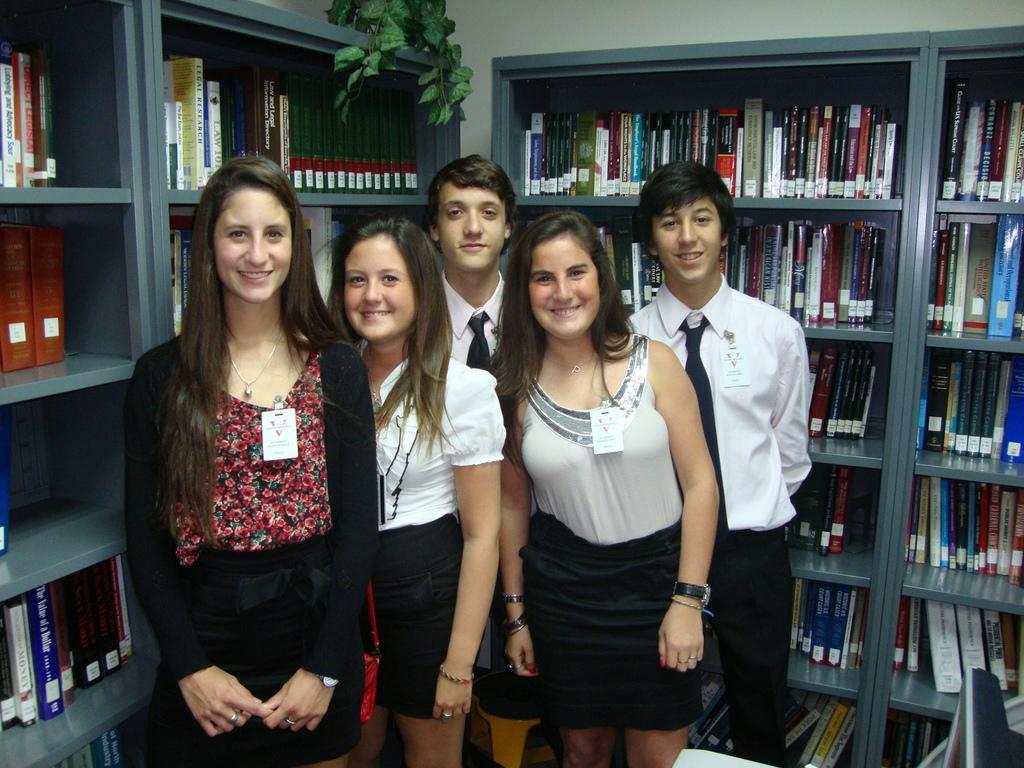Can you describe this image briefly? This picture shows few people standing. They were id cards and we see books in the bookshelves and a plant and we see a monitor on the table 